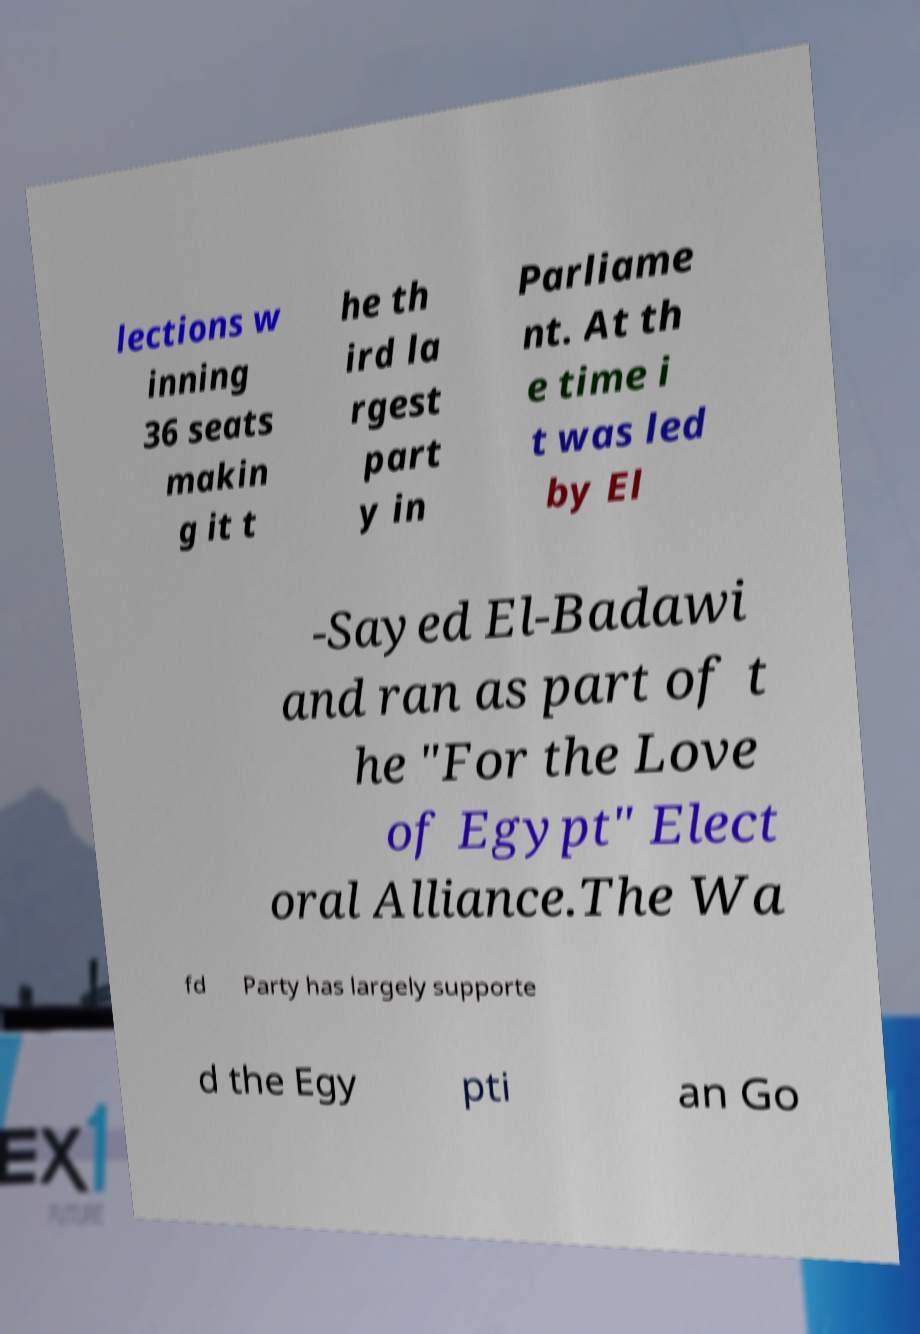Can you accurately transcribe the text from the provided image for me? lections w inning 36 seats makin g it t he th ird la rgest part y in Parliame nt. At th e time i t was led by El -Sayed El-Badawi and ran as part of t he "For the Love of Egypt" Elect oral Alliance.The Wa fd Party has largely supporte d the Egy pti an Go 